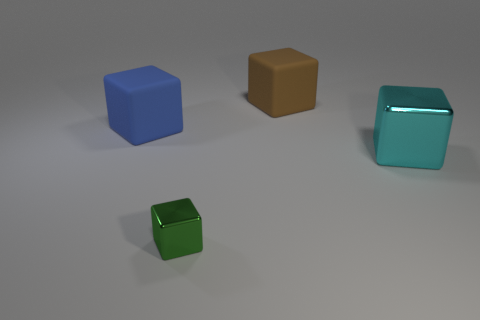What shape is the metal object right of the small metal block?
Ensure brevity in your answer.  Cube. Does the thing that is behind the blue rubber block have the same size as the metallic thing in front of the cyan block?
Your answer should be very brief. No. Is the number of brown matte things that are left of the large metallic cube greater than the number of cyan blocks that are behind the blue matte object?
Offer a terse response. Yes. Is there a big blue cylinder made of the same material as the cyan thing?
Provide a short and direct response. No. Is the big metallic cube the same color as the tiny thing?
Your answer should be compact. No. What is the object that is in front of the blue block and behind the green metal block made of?
Make the answer very short. Metal. The small metal thing is what color?
Your response must be concise. Green. What number of large gray objects have the same shape as the green metal object?
Your response must be concise. 0. Is the material of the block in front of the cyan block the same as the big cyan thing that is right of the big brown matte object?
Offer a terse response. Yes. What is the size of the matte block behind the large cube that is on the left side of the small cube?
Your answer should be very brief. Large. 